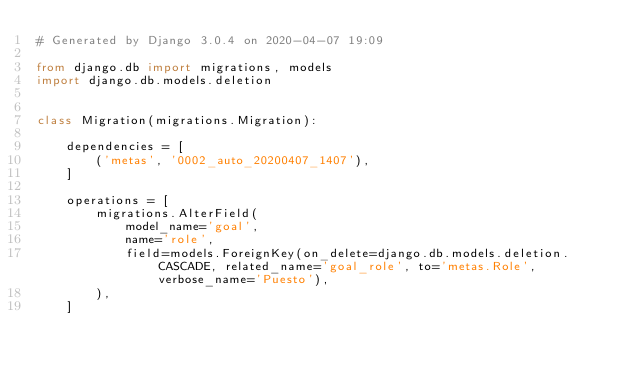<code> <loc_0><loc_0><loc_500><loc_500><_Python_># Generated by Django 3.0.4 on 2020-04-07 19:09

from django.db import migrations, models
import django.db.models.deletion


class Migration(migrations.Migration):

    dependencies = [
        ('metas', '0002_auto_20200407_1407'),
    ]

    operations = [
        migrations.AlterField(
            model_name='goal',
            name='role',
            field=models.ForeignKey(on_delete=django.db.models.deletion.CASCADE, related_name='goal_role', to='metas.Role', verbose_name='Puesto'),
        ),
    ]
</code> 